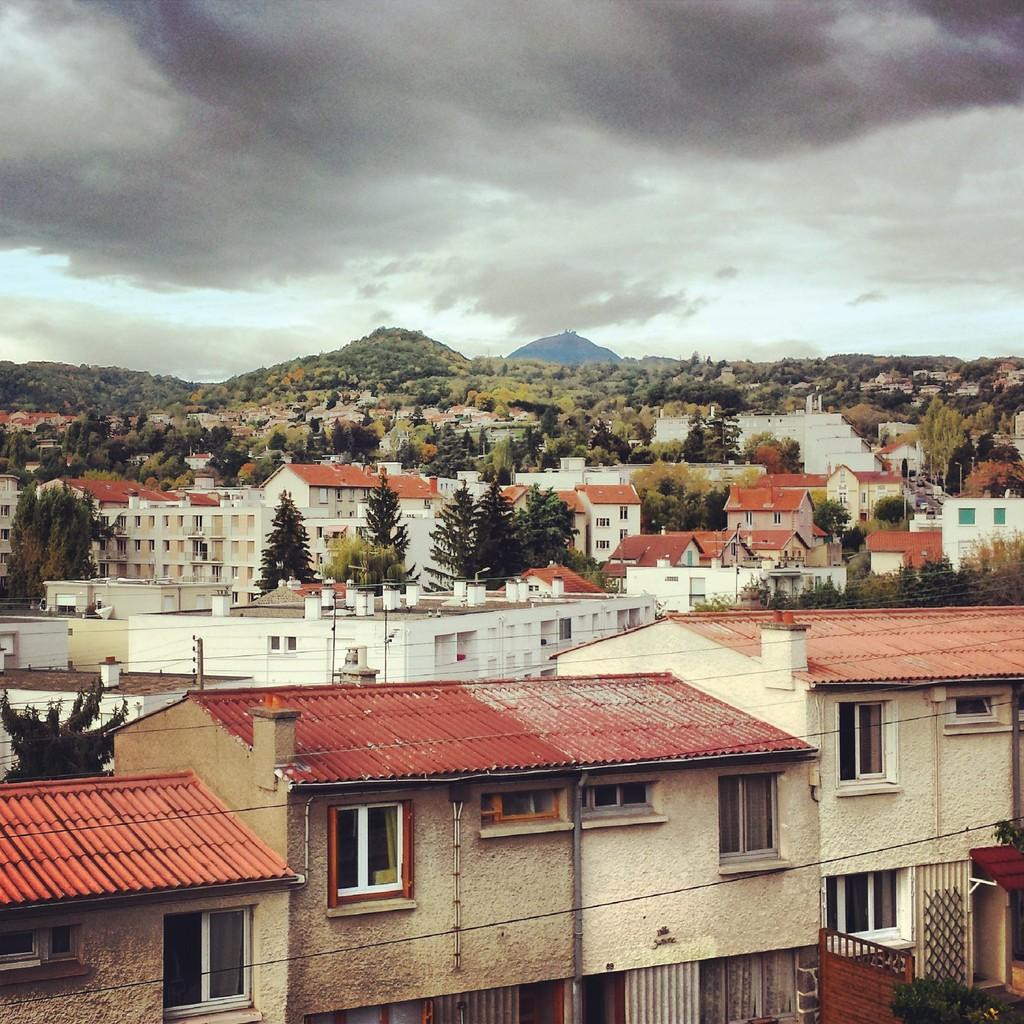What type of structures can be seen in the image? There are buildings in the image. What other natural elements are present in the image? There are trees in the image. What part of the natural environment is visible in the image? The sky is visible in the image. How would you describe the weather based on the sky in the image? The sky is cloudy in the image. What does the robin offer to the mom in the image? There is no robin or mom present in the image, so it is not possible to answer that question. 